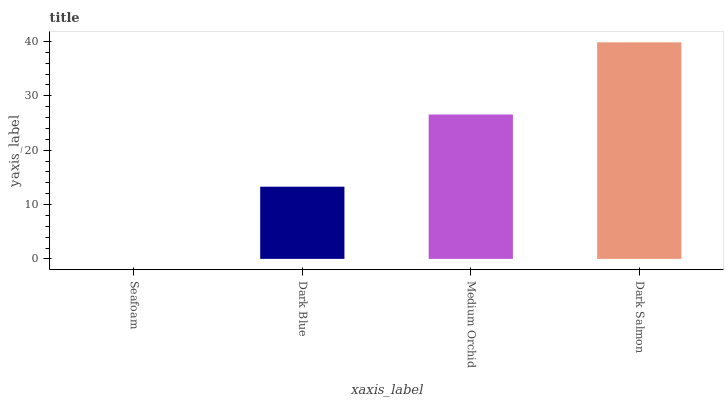Is Dark Blue the minimum?
Answer yes or no. No. Is Dark Blue the maximum?
Answer yes or no. No. Is Dark Blue greater than Seafoam?
Answer yes or no. Yes. Is Seafoam less than Dark Blue?
Answer yes or no. Yes. Is Seafoam greater than Dark Blue?
Answer yes or no. No. Is Dark Blue less than Seafoam?
Answer yes or no. No. Is Medium Orchid the high median?
Answer yes or no. Yes. Is Dark Blue the low median?
Answer yes or no. Yes. Is Dark Salmon the high median?
Answer yes or no. No. Is Seafoam the low median?
Answer yes or no. No. 